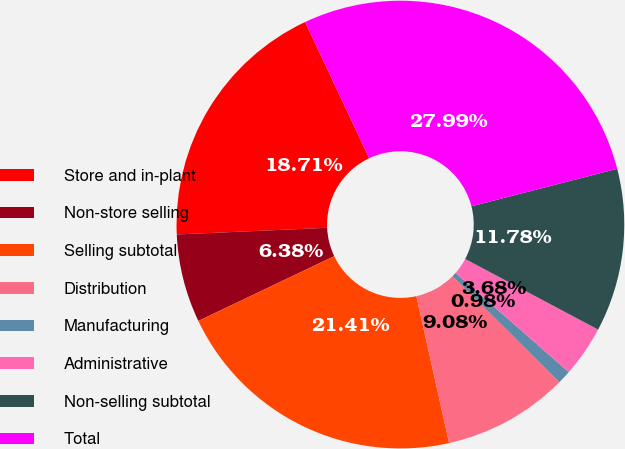Convert chart. <chart><loc_0><loc_0><loc_500><loc_500><pie_chart><fcel>Store and in-plant<fcel>Non-store selling<fcel>Selling subtotal<fcel>Distribution<fcel>Manufacturing<fcel>Administrative<fcel>Non-selling subtotal<fcel>Total<nl><fcel>18.71%<fcel>6.38%<fcel>21.41%<fcel>9.08%<fcel>0.98%<fcel>3.68%<fcel>11.78%<fcel>27.99%<nl></chart> 